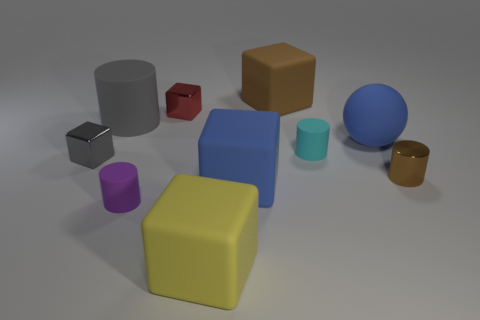Subtract all gray cubes. How many cubes are left? 4 Subtract all brown cubes. How many cubes are left? 4 Subtract all purple blocks. Subtract all blue cylinders. How many blocks are left? 5 Subtract all spheres. How many objects are left? 9 Subtract all big blue cubes. Subtract all tiny brown metal objects. How many objects are left? 8 Add 1 brown matte things. How many brown matte things are left? 2 Add 6 gray rubber objects. How many gray rubber objects exist? 7 Subtract 1 blue blocks. How many objects are left? 9 